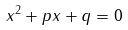<formula> <loc_0><loc_0><loc_500><loc_500>x ^ { 2 } + p x + q = 0</formula> 